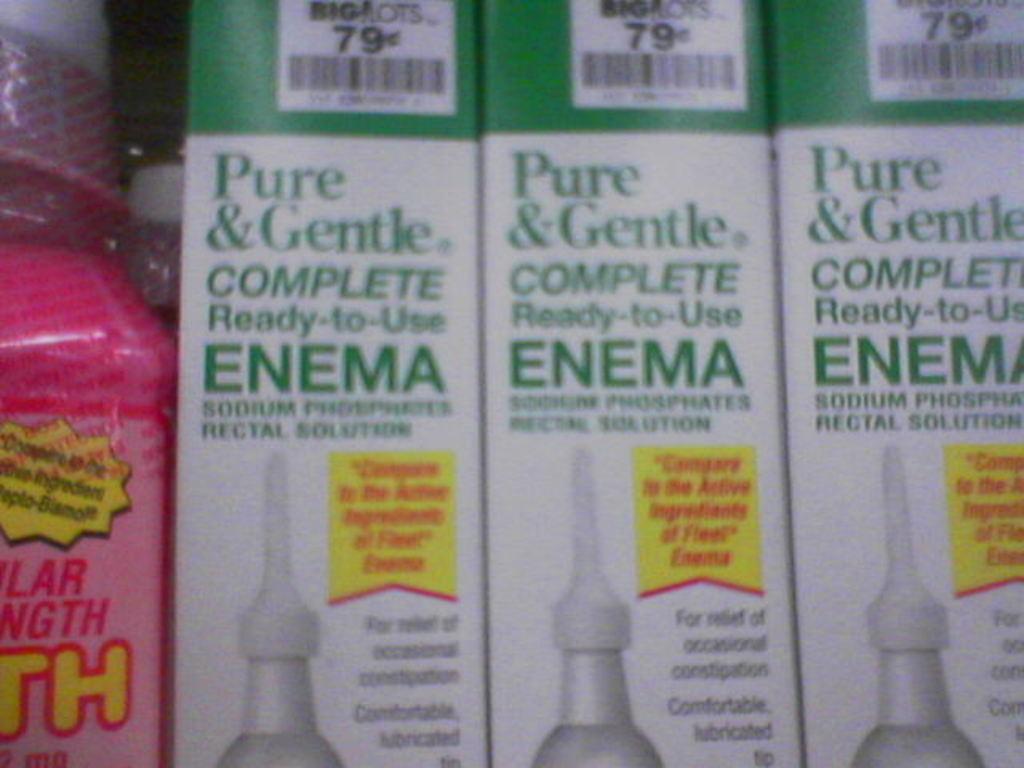Please provide a concise description of this image. In this picture there is a pink color bottle and there is a text on the bottle. There are three boxes and there is a text and there are barcodes on the boxes. 